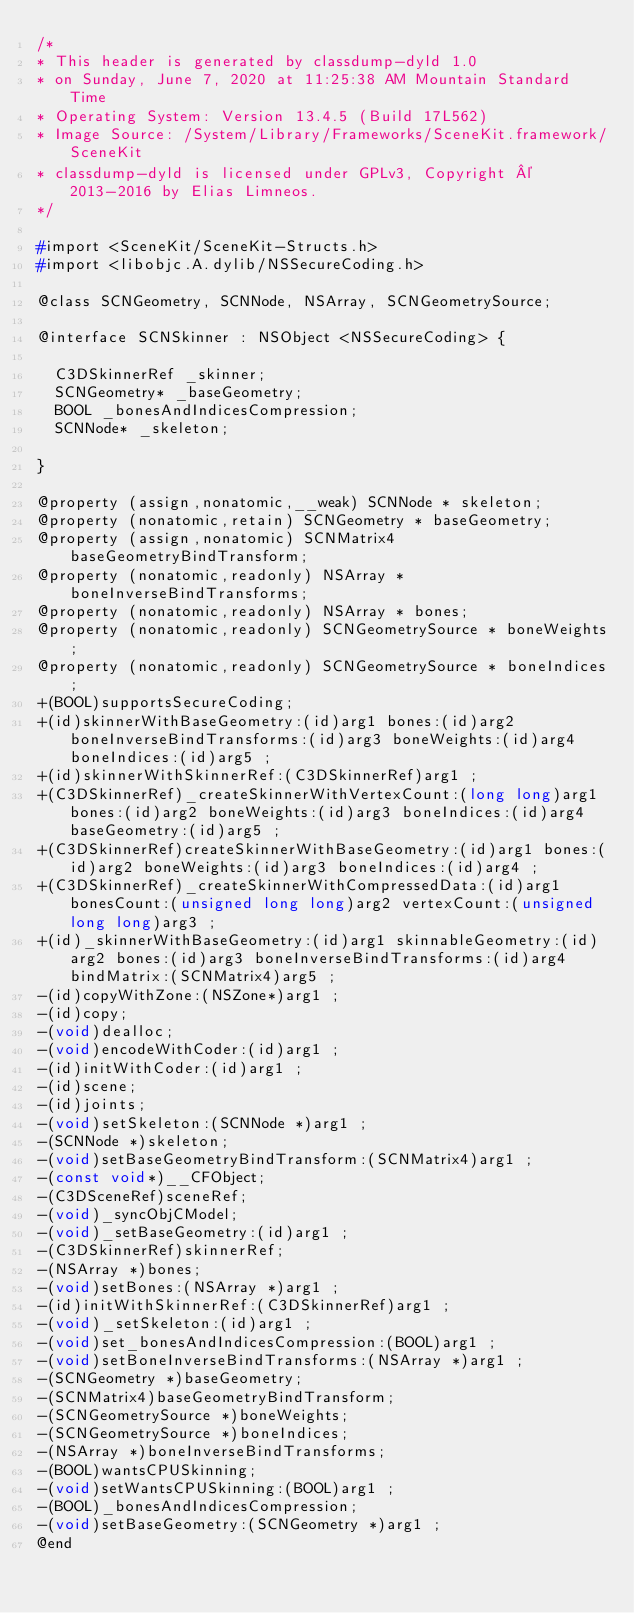<code> <loc_0><loc_0><loc_500><loc_500><_C_>/*
* This header is generated by classdump-dyld 1.0
* on Sunday, June 7, 2020 at 11:25:38 AM Mountain Standard Time
* Operating System: Version 13.4.5 (Build 17L562)
* Image Source: /System/Library/Frameworks/SceneKit.framework/SceneKit
* classdump-dyld is licensed under GPLv3, Copyright © 2013-2016 by Elias Limneos.
*/

#import <SceneKit/SceneKit-Structs.h>
#import <libobjc.A.dylib/NSSecureCoding.h>

@class SCNGeometry, SCNNode, NSArray, SCNGeometrySource;

@interface SCNSkinner : NSObject <NSSecureCoding> {

	C3DSkinnerRef _skinner;
	SCNGeometry* _baseGeometry;
	BOOL _bonesAndIndicesCompression;
	SCNNode* _skeleton;

}

@property (assign,nonatomic,__weak) SCNNode * skeleton; 
@property (nonatomic,retain) SCNGeometry * baseGeometry; 
@property (assign,nonatomic) SCNMatrix4 baseGeometryBindTransform; 
@property (nonatomic,readonly) NSArray * boneInverseBindTransforms; 
@property (nonatomic,readonly) NSArray * bones; 
@property (nonatomic,readonly) SCNGeometrySource * boneWeights; 
@property (nonatomic,readonly) SCNGeometrySource * boneIndices; 
+(BOOL)supportsSecureCoding;
+(id)skinnerWithBaseGeometry:(id)arg1 bones:(id)arg2 boneInverseBindTransforms:(id)arg3 boneWeights:(id)arg4 boneIndices:(id)arg5 ;
+(id)skinnerWithSkinnerRef:(C3DSkinnerRef)arg1 ;
+(C3DSkinnerRef)_createSkinnerWithVertexCount:(long long)arg1 bones:(id)arg2 boneWeights:(id)arg3 boneIndices:(id)arg4 baseGeometry:(id)arg5 ;
+(C3DSkinnerRef)createSkinnerWithBaseGeometry:(id)arg1 bones:(id)arg2 boneWeights:(id)arg3 boneIndices:(id)arg4 ;
+(C3DSkinnerRef)_createSkinnerWithCompressedData:(id)arg1 bonesCount:(unsigned long long)arg2 vertexCount:(unsigned long long)arg3 ;
+(id)_skinnerWithBaseGeometry:(id)arg1 skinnableGeometry:(id)arg2 bones:(id)arg3 boneInverseBindTransforms:(id)arg4 bindMatrix:(SCNMatrix4)arg5 ;
-(id)copyWithZone:(NSZone*)arg1 ;
-(id)copy;
-(void)dealloc;
-(void)encodeWithCoder:(id)arg1 ;
-(id)initWithCoder:(id)arg1 ;
-(id)scene;
-(id)joints;
-(void)setSkeleton:(SCNNode *)arg1 ;
-(SCNNode *)skeleton;
-(void)setBaseGeometryBindTransform:(SCNMatrix4)arg1 ;
-(const void*)__CFObject;
-(C3DSceneRef)sceneRef;
-(void)_syncObjCModel;
-(void)_setBaseGeometry:(id)arg1 ;
-(C3DSkinnerRef)skinnerRef;
-(NSArray *)bones;
-(void)setBones:(NSArray *)arg1 ;
-(id)initWithSkinnerRef:(C3DSkinnerRef)arg1 ;
-(void)_setSkeleton:(id)arg1 ;
-(void)set_bonesAndIndicesCompression:(BOOL)arg1 ;
-(void)setBoneInverseBindTransforms:(NSArray *)arg1 ;
-(SCNGeometry *)baseGeometry;
-(SCNMatrix4)baseGeometryBindTransform;
-(SCNGeometrySource *)boneWeights;
-(SCNGeometrySource *)boneIndices;
-(NSArray *)boneInverseBindTransforms;
-(BOOL)wantsCPUSkinning;
-(void)setWantsCPUSkinning:(BOOL)arg1 ;
-(BOOL)_bonesAndIndicesCompression;
-(void)setBaseGeometry:(SCNGeometry *)arg1 ;
@end

</code> 